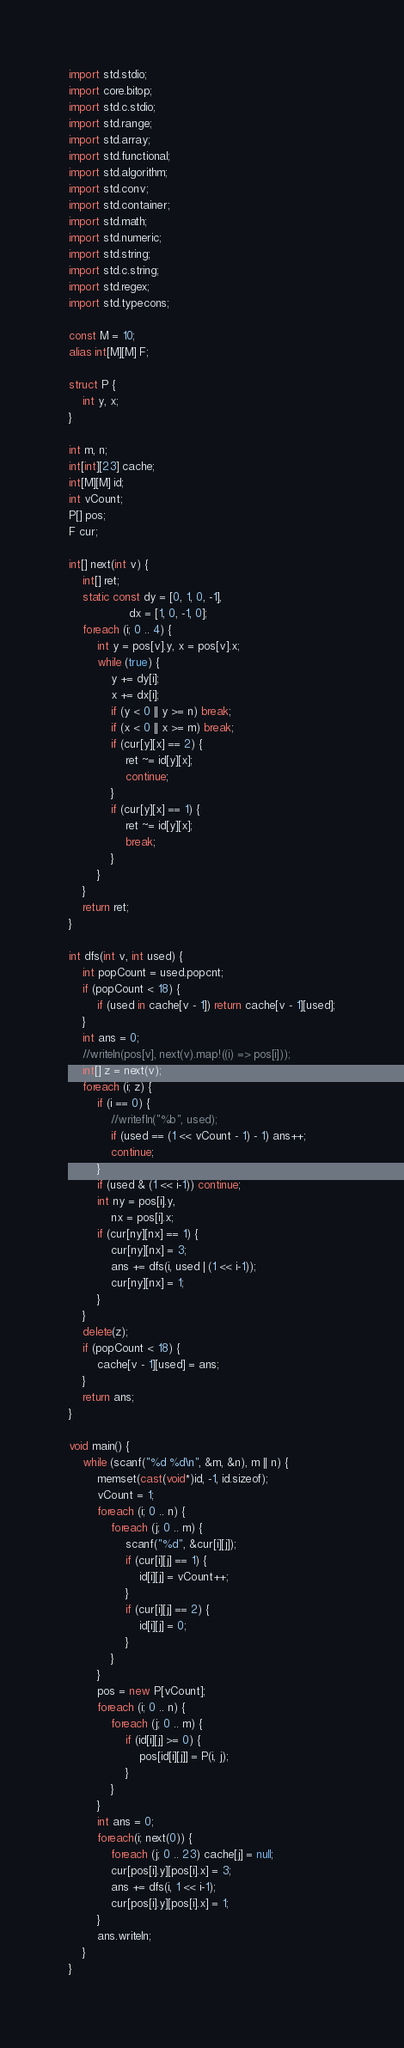Convert code to text. <code><loc_0><loc_0><loc_500><loc_500><_D_>import std.stdio;
import core.bitop;
import std.c.stdio;
import std.range;
import std.array;
import std.functional;
import std.algorithm;
import std.conv;
import std.container;
import std.math;
import std.numeric;
import std.string;
import std.c.string;
import std.regex;
import std.typecons;

const M = 10;
alias int[M][M] F;

struct P {
    int y, x;
}

int m, n;
int[int][23] cache;
int[M][M] id;
int vCount;
P[] pos;
F cur;

int[] next(int v) {
    int[] ret;
    static const dy = [0, 1, 0, -1],
                 dx = [1, 0, -1, 0];
    foreach (i; 0 .. 4) {
        int y = pos[v].y, x = pos[v].x;
        while (true) {
            y += dy[i];
            x += dx[i];
            if (y < 0 || y >= n) break;
            if (x < 0 || x >= m) break;
            if (cur[y][x] == 2) {
                ret ~= id[y][x];
                continue;
            }
            if (cur[y][x] == 1) {
                ret ~= id[y][x];
                break;
            }
        }
    }
    return ret;
}

int dfs(int v, int used) {
    int popCount = used.popcnt;
    if (popCount < 18) {
        if (used in cache[v - 1]) return cache[v - 1][used];
    }
    int ans = 0;
    //writeln(pos[v], next(v).map!((i) => pos[i]));
    int[] z = next(v);
    foreach (i; z) {
        if (i == 0) {
            //writefln("%b", used);
            if (used == (1 << vCount - 1) - 1) ans++;
            continue;
        }
        if (used & (1 << i-1)) continue;
        int ny = pos[i].y,
            nx = pos[i].x;
        if (cur[ny][nx] == 1) {
            cur[ny][nx] = 3;
            ans += dfs(i, used | (1 << i-1));
            cur[ny][nx] = 1;
        } 
    }
    delete(z);
    if (popCount < 18) {
        cache[v - 1][used] = ans;
    }
    return ans;
}

void main() {
    while (scanf("%d %d\n", &m, &n), m || n) {
        memset(cast(void*)id, -1, id.sizeof);
        vCount = 1;
        foreach (i; 0 .. n) {
            foreach (j; 0 .. m) {
                scanf("%d", &cur[i][j]);
                if (cur[i][j] == 1) {
                    id[i][j] = vCount++;
                }
                if (cur[i][j] == 2) {
                    id[i][j] = 0;
                }
            }
        }
        pos = new P[vCount];
        foreach (i; 0 .. n) {
            foreach (j; 0 .. m) {
                if (id[i][j] >= 0) {
                    pos[id[i][j]] = P(i, j);
                }
            }
        }
        int ans = 0;
        foreach(i; next(0)) {
            foreach (j; 0 .. 23) cache[j] = null;
            cur[pos[i].y][pos[i].x] = 3;
            ans += dfs(i, 1 << i-1);
            cur[pos[i].y][pos[i].x] = 1;
        }
        ans.writeln;
    }
}</code> 